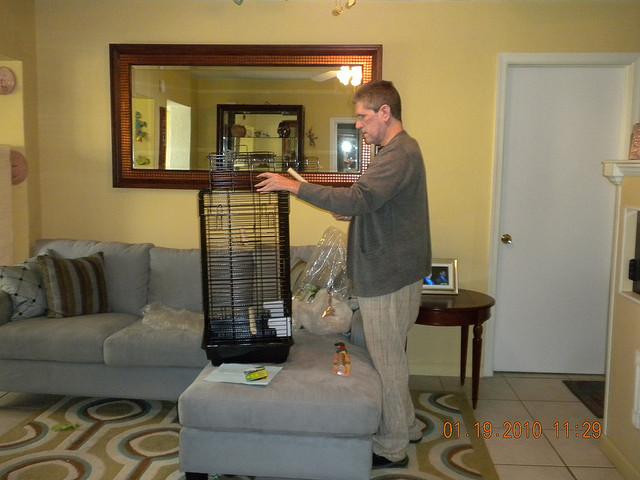Is the man wearing shoes?
Give a very brief answer. Yes. Is the a cage in this photo?
Keep it brief. Yes. What room is the man standing in the photo?
Be succinct. Living room. Is this a corner couch?
Short answer required. Yes. 